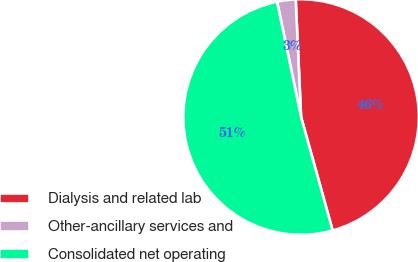Convert chart. <chart><loc_0><loc_0><loc_500><loc_500><pie_chart><fcel>Dialysis and related lab<fcel>Other-ancillary services and<fcel>Consolidated net operating<nl><fcel>46.41%<fcel>2.54%<fcel>51.05%<nl></chart> 